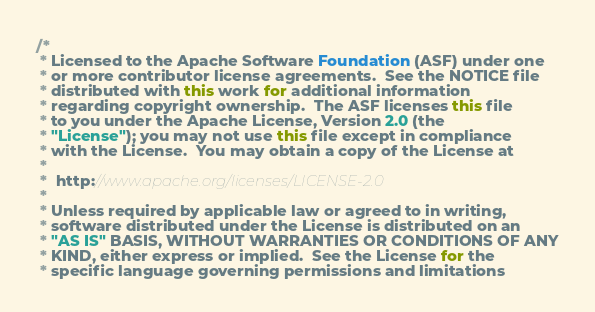<code> <loc_0><loc_0><loc_500><loc_500><_Java_>/*
 * Licensed to the Apache Software Foundation (ASF) under one
 * or more contributor license agreements.  See the NOTICE file
 * distributed with this work for additional information
 * regarding copyright ownership.  The ASF licenses this file
 * to you under the Apache License, Version 2.0 (the
 * "License"); you may not use this file except in compliance
 * with the License.  You may obtain a copy of the License at
 *
 *  http://www.apache.org/licenses/LICENSE-2.0
 *
 * Unless required by applicable law or agreed to in writing,
 * software distributed under the License is distributed on an
 * "AS IS" BASIS, WITHOUT WARRANTIES OR CONDITIONS OF ANY
 * KIND, either express or implied.  See the License for the
 * specific language governing permissions and limitations</code> 